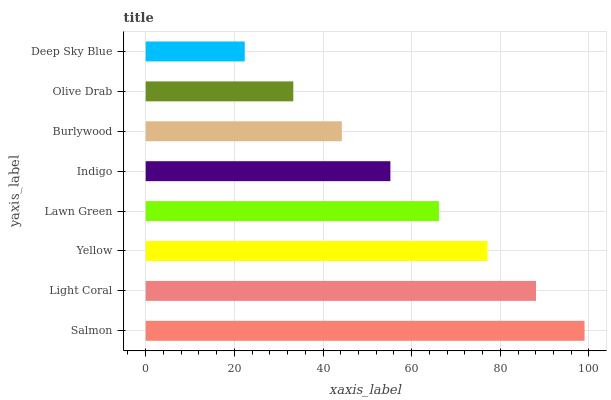Is Deep Sky Blue the minimum?
Answer yes or no. Yes. Is Salmon the maximum?
Answer yes or no. Yes. Is Light Coral the minimum?
Answer yes or no. No. Is Light Coral the maximum?
Answer yes or no. No. Is Salmon greater than Light Coral?
Answer yes or no. Yes. Is Light Coral less than Salmon?
Answer yes or no. Yes. Is Light Coral greater than Salmon?
Answer yes or no. No. Is Salmon less than Light Coral?
Answer yes or no. No. Is Lawn Green the high median?
Answer yes or no. Yes. Is Indigo the low median?
Answer yes or no. Yes. Is Burlywood the high median?
Answer yes or no. No. Is Burlywood the low median?
Answer yes or no. No. 